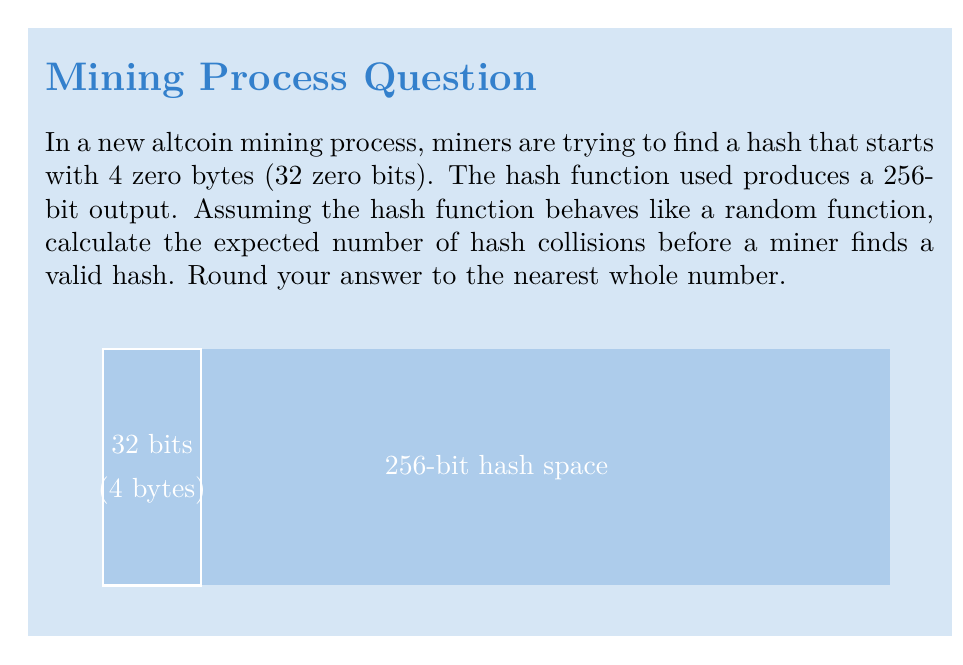Solve this math problem. Let's approach this step-by-step:

1) The probability of finding a hash with 4 zero bytes is:
   $$p = \frac{1}{2^{32}} = \frac{1}{4,294,967,296}$$

2) The expected number of attempts before finding a valid hash follows a geometric distribution with parameter $p$. The expected value is:
   $$E[X] = \frac{1}{p} = 2^{32} = 4,294,967,296$$

3) Now, we need to calculate the expected number of collisions before finding this valid hash. This is equivalent to the expected number of duplicate items when sampling with replacement until we get a specific item.

4) This problem is known as the "coupon collector's problem with a golden coupon". The expected number of collisions is:
   $$E[C] = \frac{n-1}{2}$$
   where $n$ is the expected number of attempts.

5) Substituting our value for $n$:
   $$E[C] = \frac{4,294,967,296 - 1}{2} = 2,147,483,647.5$$

6) Rounding to the nearest whole number:
   $$E[C] \approx 2,147,483,648$$

This means that, on average, a miner would expect to encounter about 2.15 billion hash collisions before finding a valid hash that starts with 4 zero bytes.
Answer: 2,147,483,648 collisions 